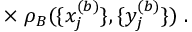Convert formula to latex. <formula><loc_0><loc_0><loc_500><loc_500>\times \, \rho _ { B } ( \{ x _ { j } ^ { ( b ) } \} , \{ y _ { j } ^ { ( b ) } \} ) \, .</formula> 